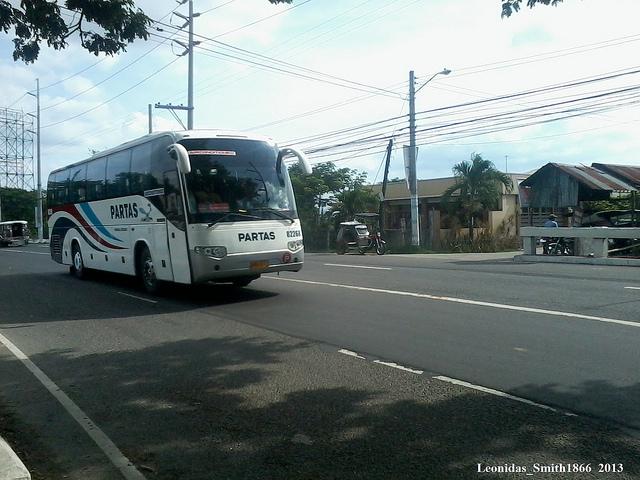Is there litter?
Concise answer only. No. What is the name written at the edge of the photo?
Short answer required. Leonidas smith. Has it been raining?
Write a very short answer. No. Is this a crowded street?
Quick response, please. No. How many buses are there?
Concise answer only. 1. What style are the lights on the lamp post?
Concise answer only. Halogen. Is this vehicle powered by those power lines?
Keep it brief. No. Are the streets wet in this picture?
Write a very short answer. No. What is the color of the bus?
Quick response, please. White. How many buses can be seen?
Concise answer only. 1. What is the number of the bus?
Quick response, please. No number. How many buses?
Concise answer only. 1. 